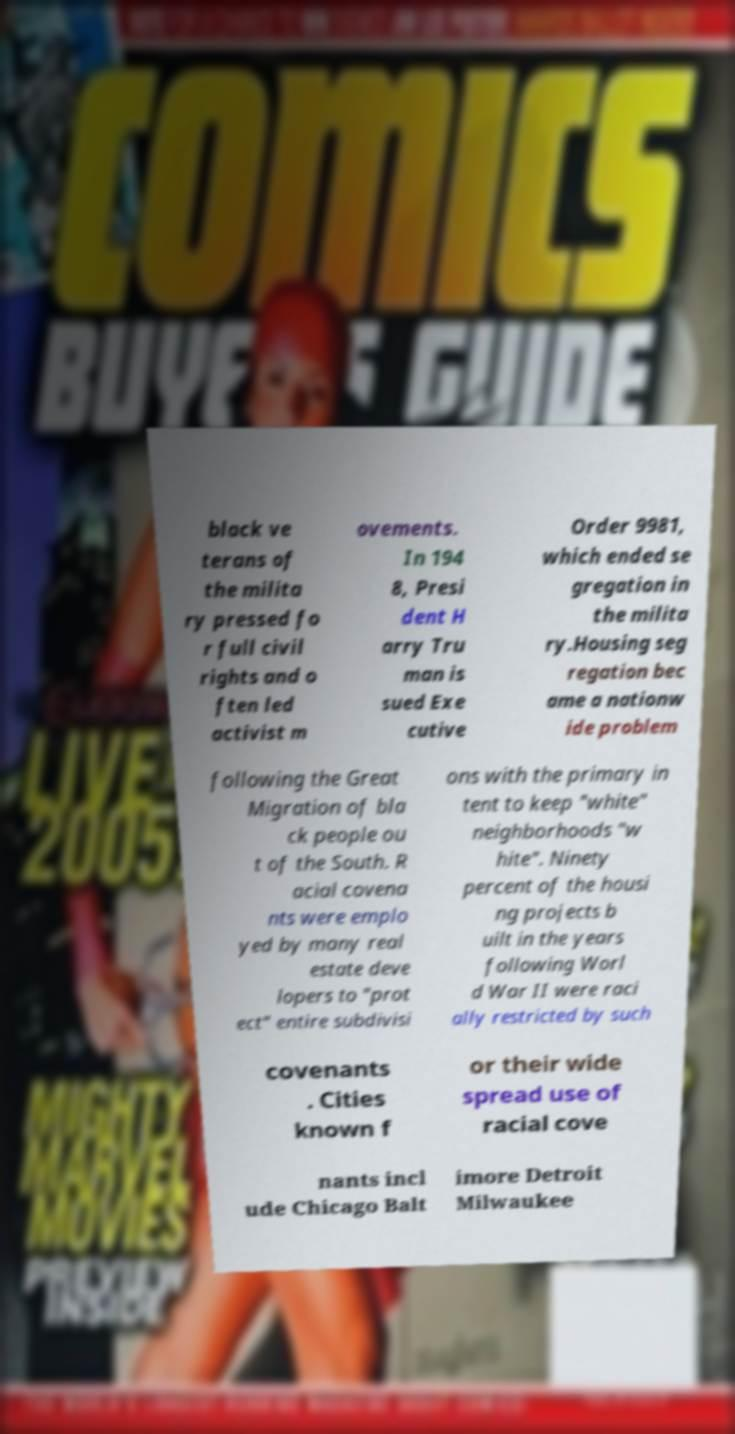Could you extract and type out the text from this image? black ve terans of the milita ry pressed fo r full civil rights and o ften led activist m ovements. In 194 8, Presi dent H arry Tru man is sued Exe cutive Order 9981, which ended se gregation in the milita ry.Housing seg regation bec ame a nationw ide problem following the Great Migration of bla ck people ou t of the South. R acial covena nts were emplo yed by many real estate deve lopers to "prot ect" entire subdivisi ons with the primary in tent to keep "white" neighborhoods "w hite". Ninety percent of the housi ng projects b uilt in the years following Worl d War II were raci ally restricted by such covenants . Cities known f or their wide spread use of racial cove nants incl ude Chicago Balt imore Detroit Milwaukee 